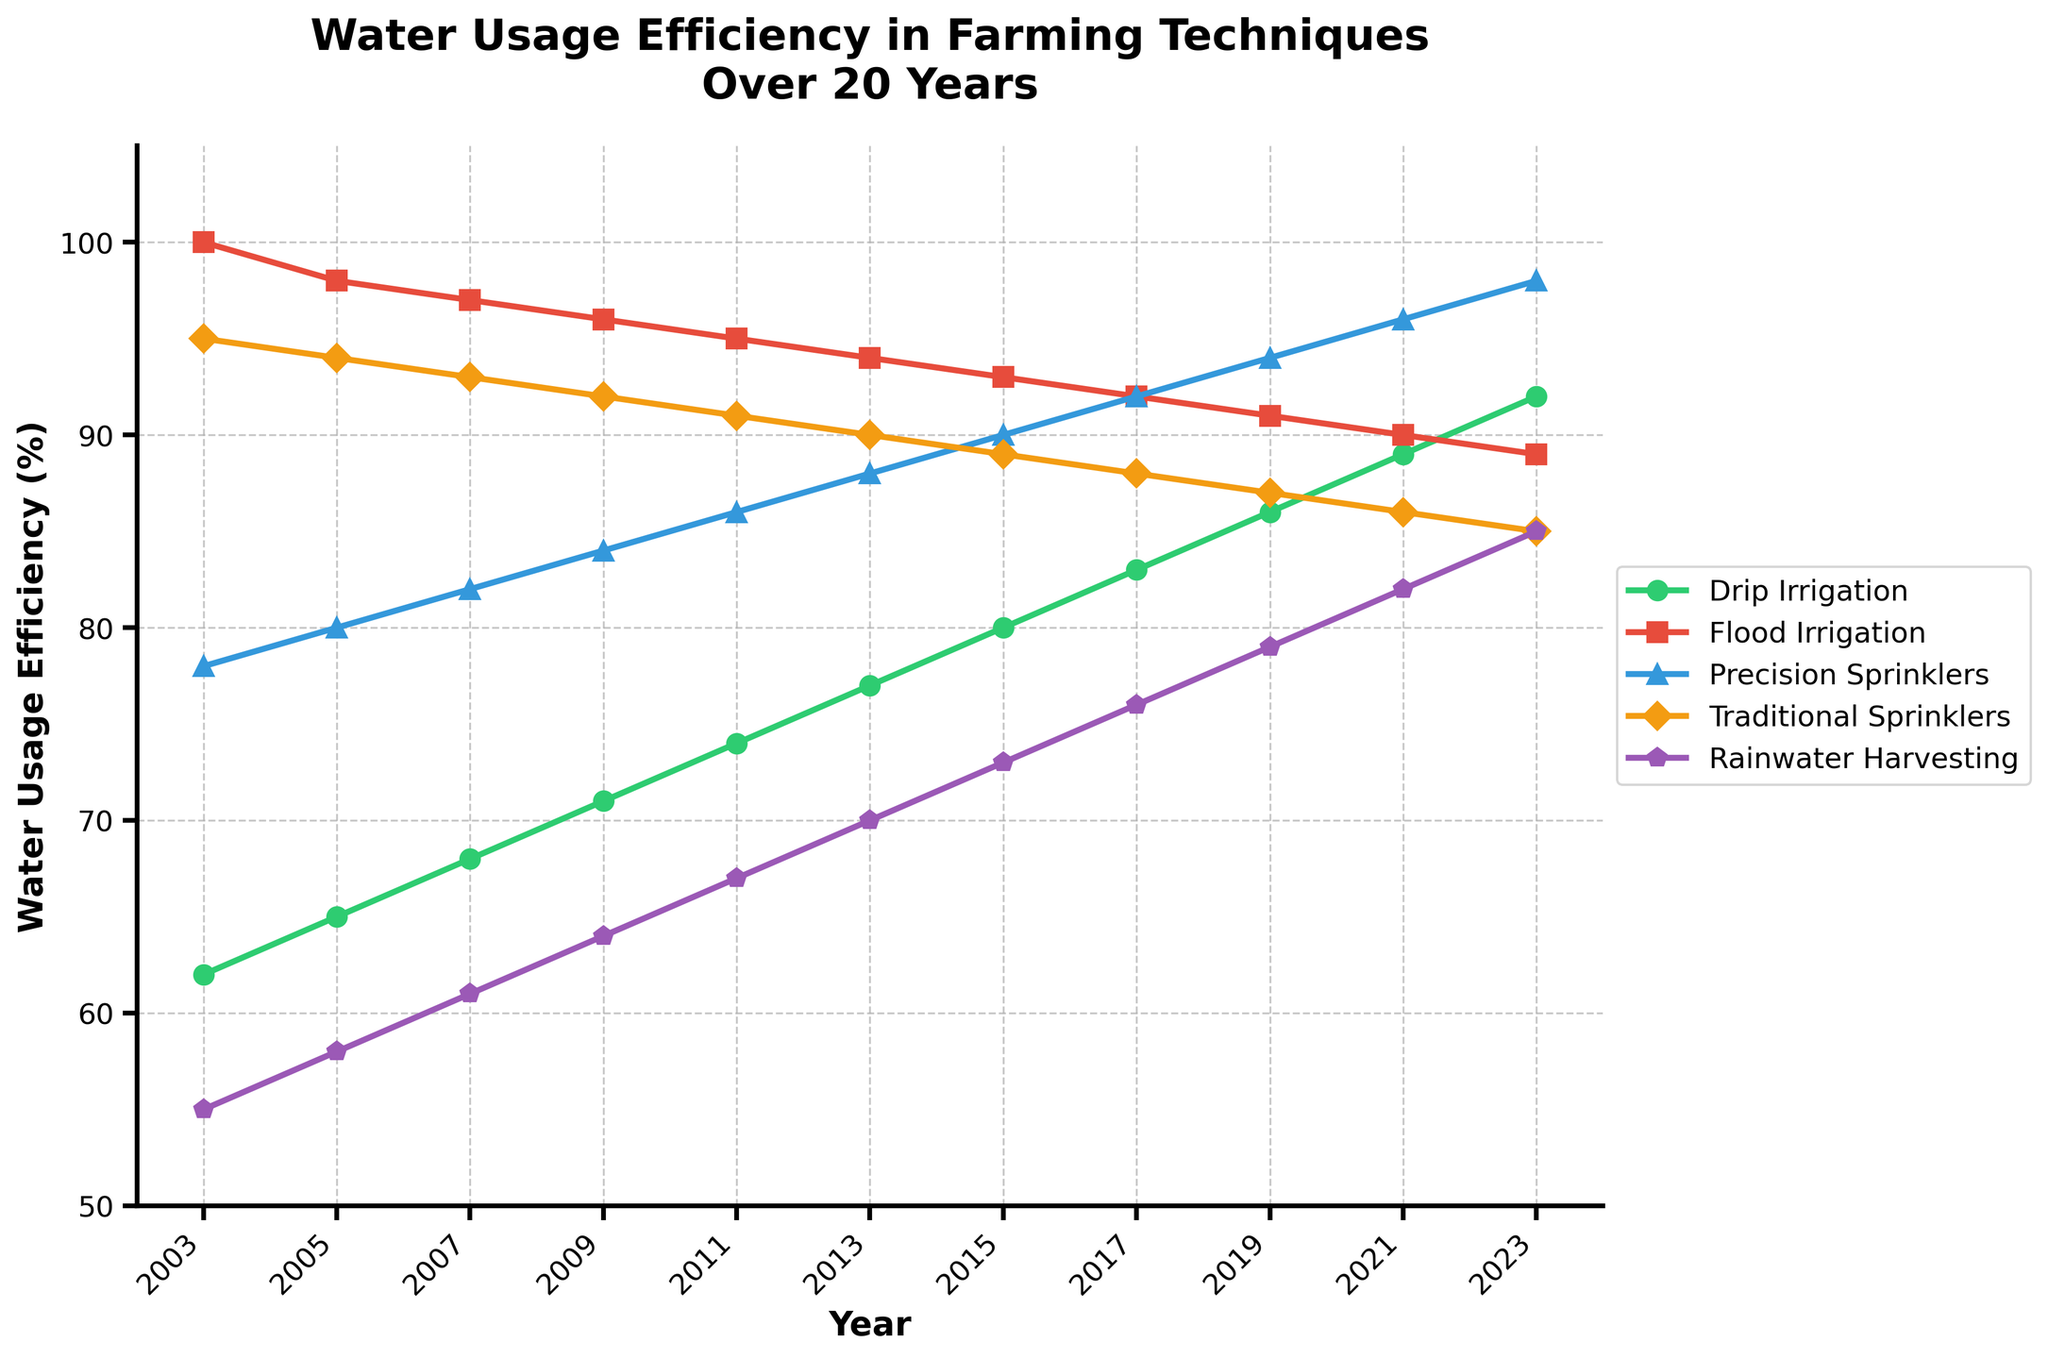What trend can be observed in the water usage efficiency of Drip Irrigation over the 20-year period? To determine the trend, we observe the points for Drip Irrigation across the years from 2003 to 2023. There is a consistent increase in water usage efficiency starting from 62% in 2003 to 92% in 2023.
Answer: Gradual increase Which farming technique had the highest water usage efficiency in 2023? By examining the end of each line on the plot for the year 2023, we see that Precision Sprinklers had the highest value at 98%.
Answer: Precision Sprinklers How does the water usage efficiency of Flood Irrigation in 2009 compare to that in 2021? Looking at the Flood Irrigation line, the value in 2009 is 96%, and it decreases to 90% in 2021.
Answer: Decreased Between Rainwater Harvesting and Traditional Sprinklers, which technique showed a bigger improvement in water usage efficiency from 2003 to 2023? Rainwater Harvesting improved from 55% to 85%, a 30% increase. Traditional Sprinklers improved from 95% to 85%, a 10% decrease.
Answer: Rainwater Harvesting In which year did Drip Irrigation surpass 80% efficiency? Observing the Drip Irrigation line, it crosses 80% between 2015 and 2017. In 2017, it is at 83%, indicating it surpassed 80% in that year.
Answer: 2017 What is the average water usage efficiency of Precision Sprinklers over the 20-year period? Sum all the efficiencies of Precision Sprinklers and divide by the number of data points: (78+80+82+84+86+88+90+92+94+96+98)/11 = 88.
Answer: 88 Subtract Flood Irrigation's efficiency in 2013 from that in 2003, and then add the difference to the efficiency of Rainwater Harvesting in 2013. What is the result? (100-94) + 70 = 6 + 70 = 76
Answer: 76 Identify the two techniques that have shown a decreasing trend over the years. By observing the lines on the chart, Flood Irrigation and Traditional Sprinklers both show a decreasing trend from 2003 to 2023.
Answer: Flood Irrigation, Traditional Sprinklers What is the visual difference between the lines representing Precision Sprinklers and Traditional Sprinklers? The line for Precision Sprinklers is blue with upward triangles, while the line for Traditional Sprinklers is orange with diamonds, denoting different visual markers and colors.
Answer: Colors and markers In which years did Rainwater Harvesting have the lowest water usage efficiency among all the techniques? By scanning the Rainwater Harvesting line against others each year, it is the lowest in 2003, 2005, 2007, and 2009.
Answer: 2003, 2005, 2007, 2009 